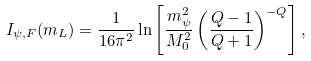Convert formula to latex. <formula><loc_0><loc_0><loc_500><loc_500>I _ { \psi , F } ( m _ { L } ) = \frac { 1 } { 1 6 \pi ^ { 2 } } \ln \left [ \frac { m _ { \psi } ^ { 2 } } { M _ { 0 } ^ { 2 } } \left ( \frac { Q - 1 } { Q + 1 } \right ) ^ { - Q } \right ] ,</formula> 